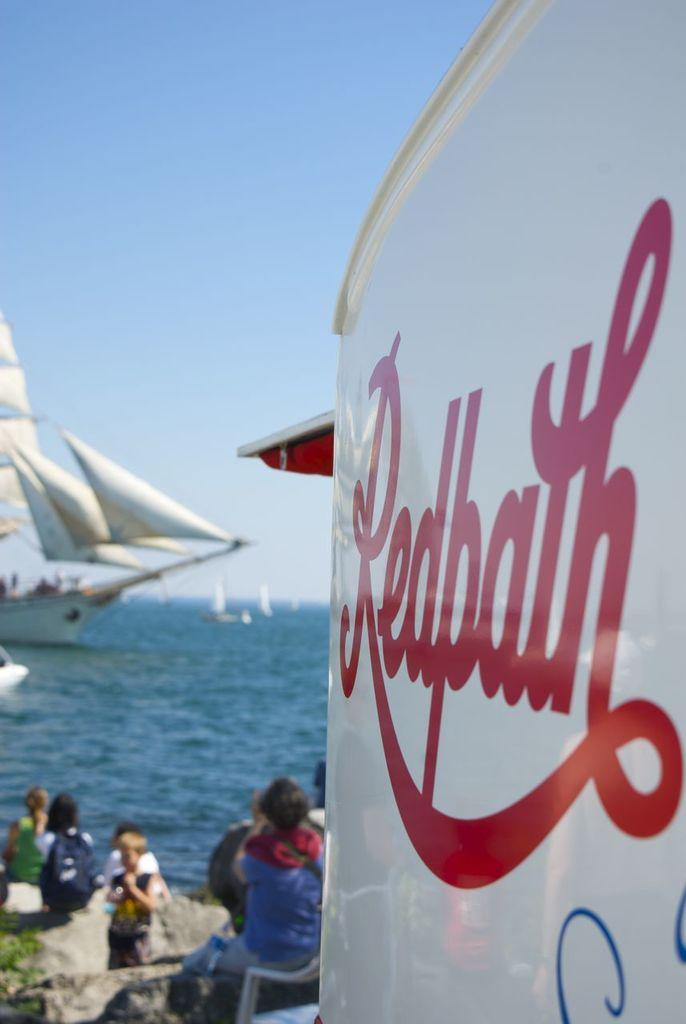Provide a one-sentence caption for the provided image. A white sign, reading Redpath, is in front of some people. 